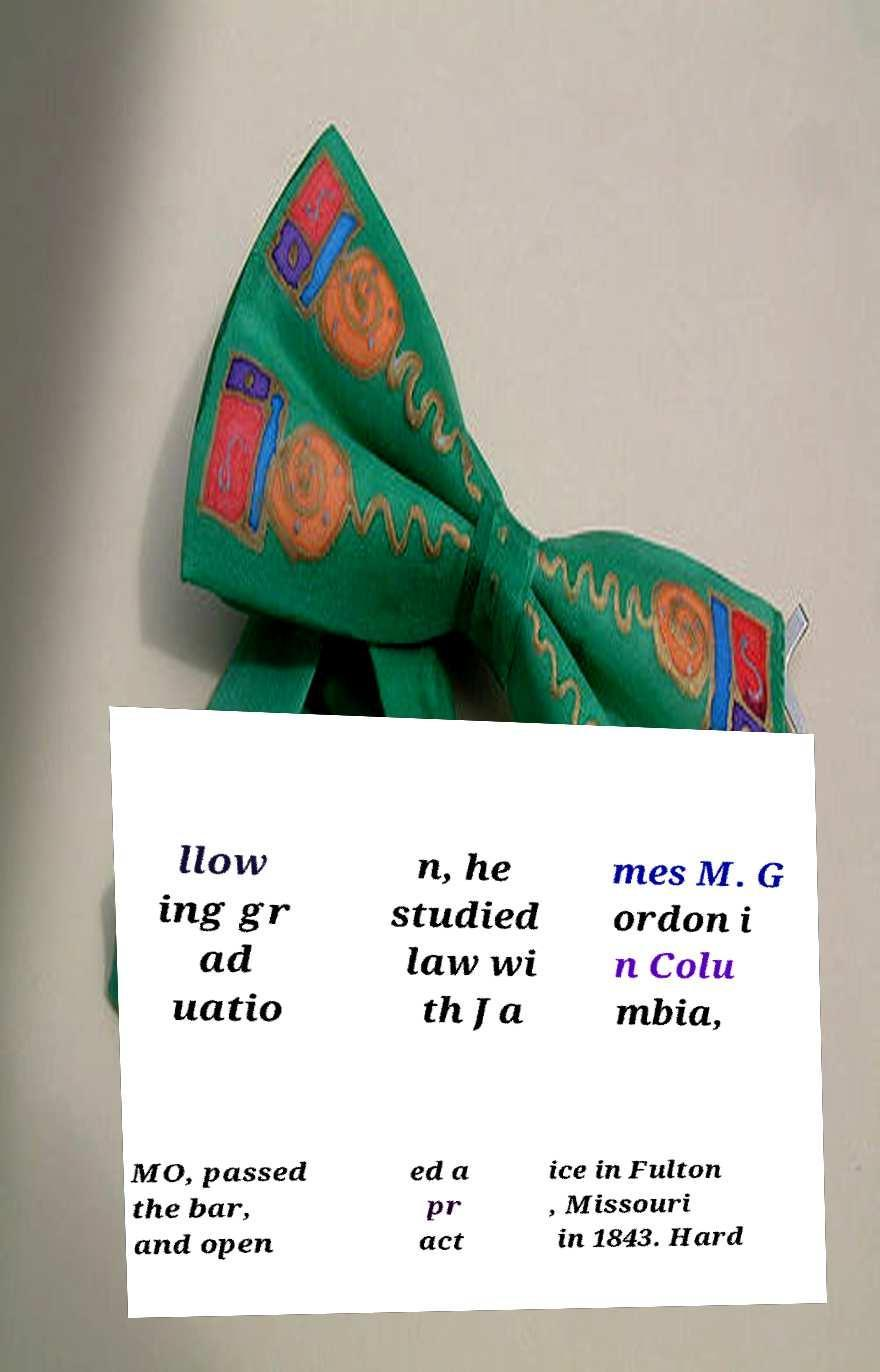What messages or text are displayed in this image? I need them in a readable, typed format. llow ing gr ad uatio n, he studied law wi th Ja mes M. G ordon i n Colu mbia, MO, passed the bar, and open ed a pr act ice in Fulton , Missouri in 1843. Hard 